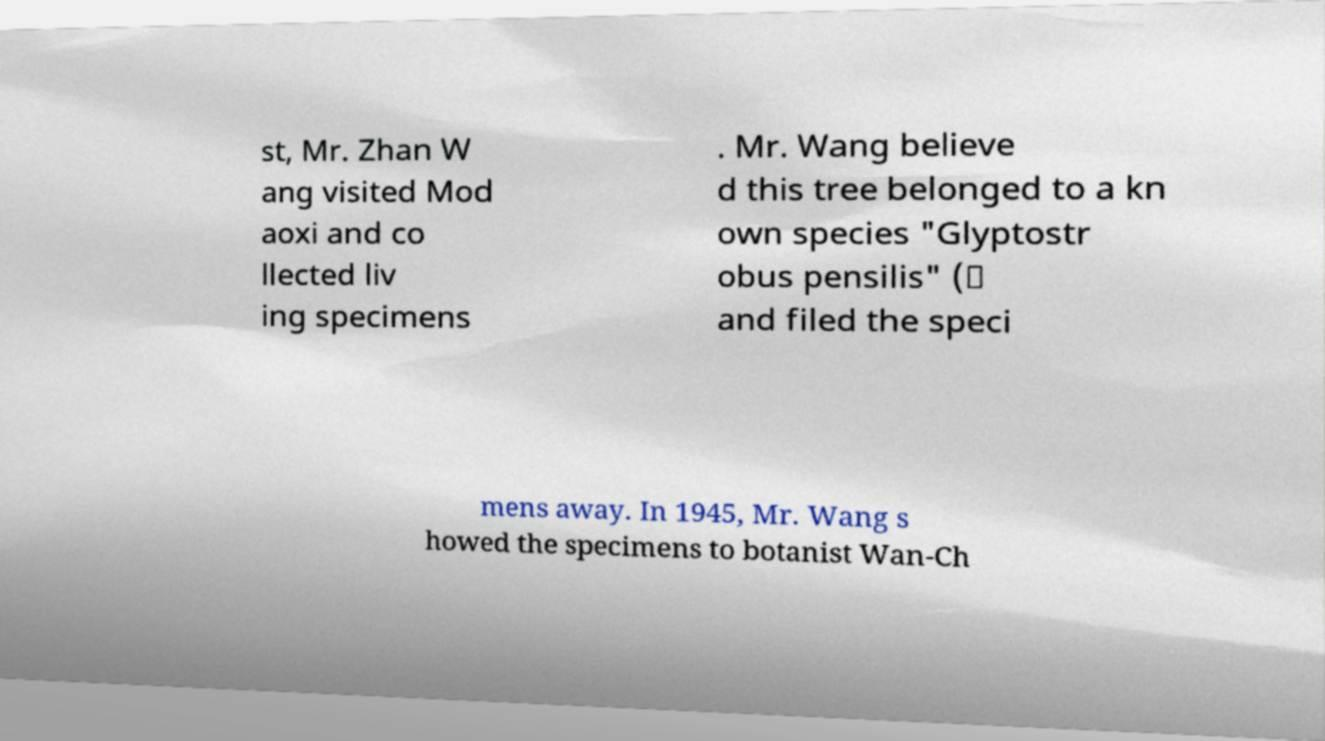Can you read and provide the text displayed in the image?This photo seems to have some interesting text. Can you extract and type it out for me? st, Mr. Zhan W ang visited Mod aoxi and co llected liv ing specimens . Mr. Wang believe d this tree belonged to a kn own species "Glyptostr obus pensilis" (） and filed the speci mens away. In 1945, Mr. Wang s howed the specimens to botanist Wan-Ch 